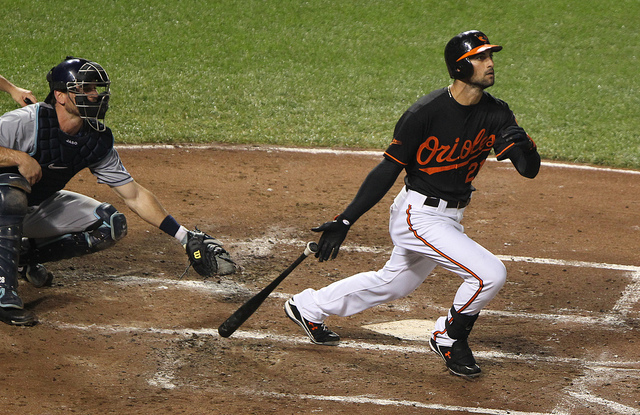Read and extract the text from this image. Oriolca 